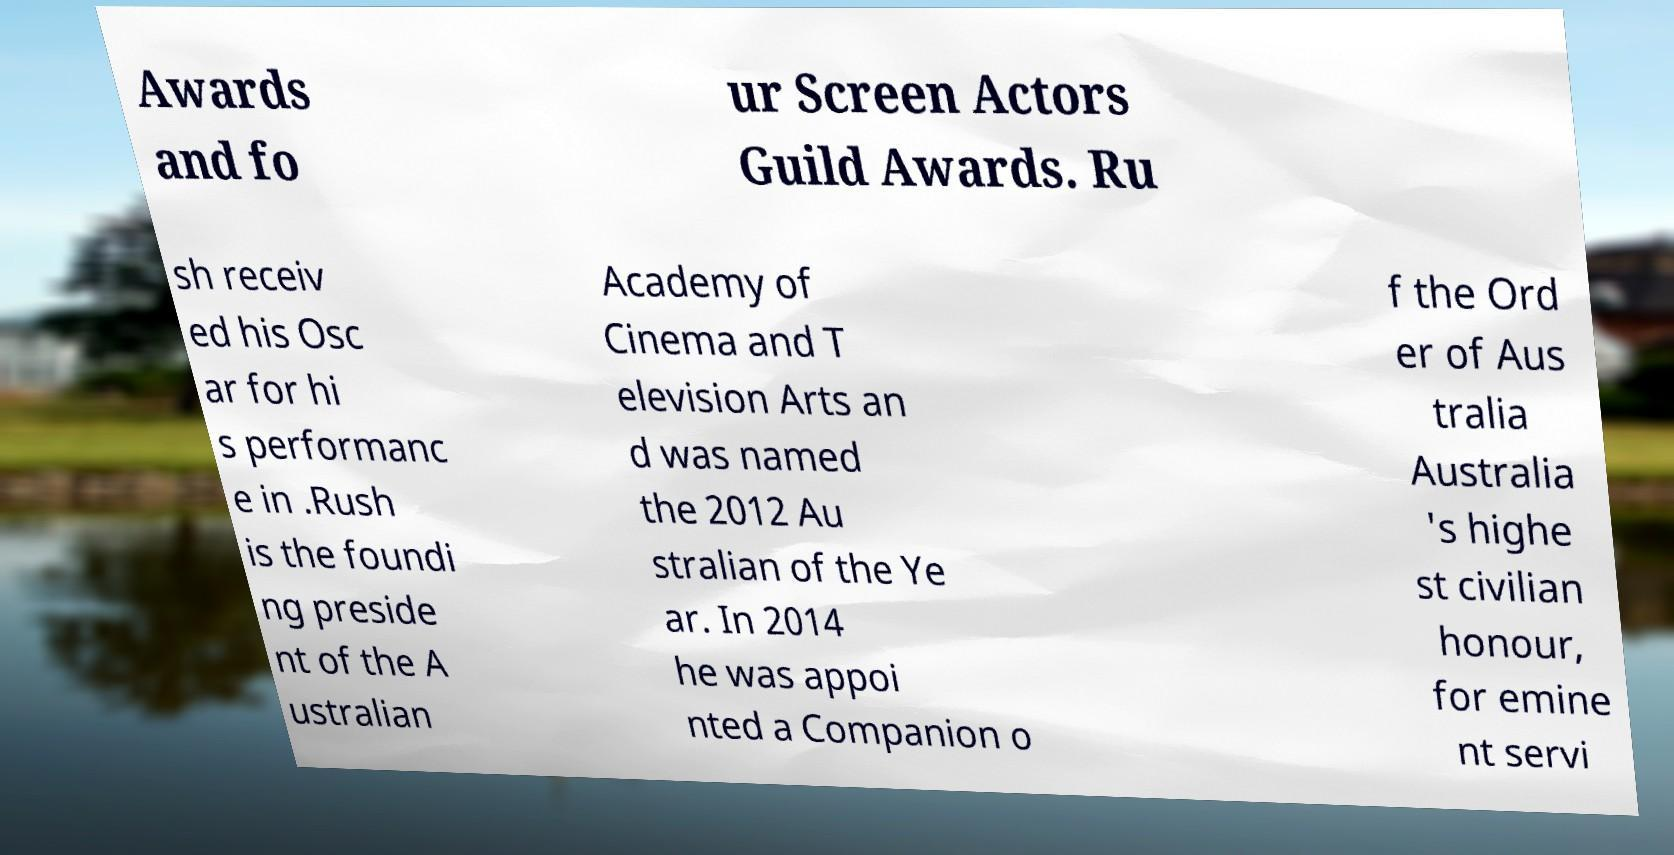Please read and relay the text visible in this image. What does it say? Awards and fo ur Screen Actors Guild Awards. Ru sh receiv ed his Osc ar for hi s performanc e in .Rush is the foundi ng preside nt of the A ustralian Academy of Cinema and T elevision Arts an d was named the 2012 Au stralian of the Ye ar. In 2014 he was appoi nted a Companion o f the Ord er of Aus tralia Australia 's highe st civilian honour, for emine nt servi 